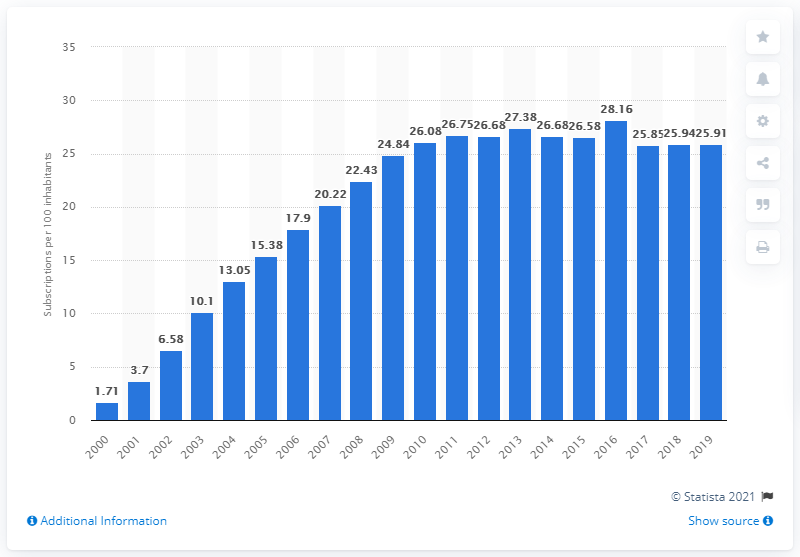List a handful of essential elements in this visual. In 2019, there were 25.91 fixed broadband subscriptions for every 100 inhabitants in Singapore. 